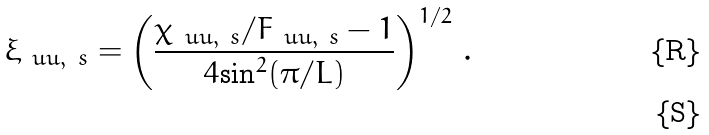<formula> <loc_0><loc_0><loc_500><loc_500>\xi _ { \ u u , \ s } = \left ( \frac { \chi _ { \ u u , \ s } / F _ { \ u u , \ s } - 1 } { 4 { \sin } ^ { 2 } ( \pi / L ) } \right ) ^ { 1 / 2 } \, . \\</formula> 